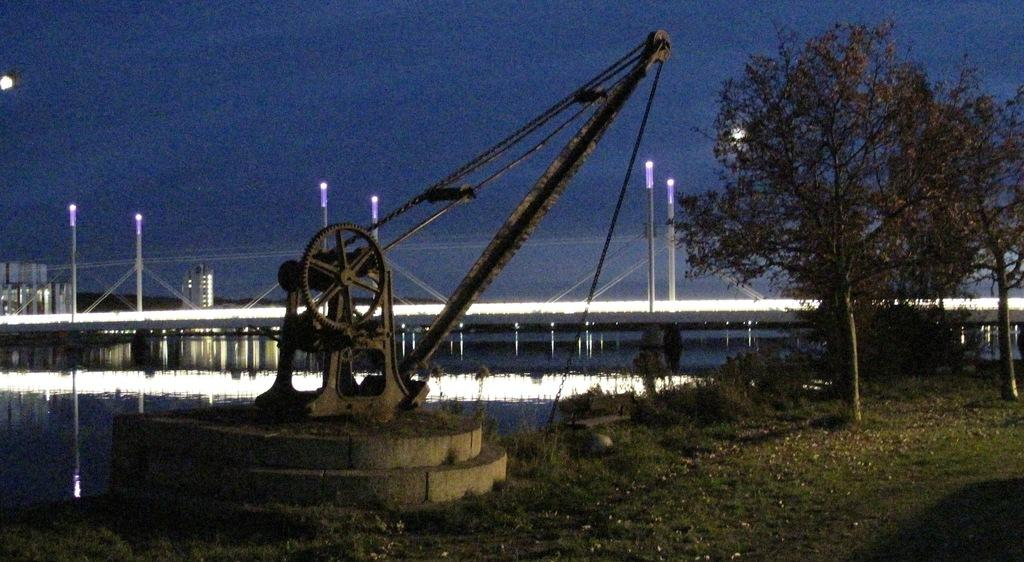What mechanical device is present in the image? There is a pulley in the image. What type of natural environment surrounds the pulley? There is grass beside the pulley. What type of plant can be seen in the image? There is a tree in the image. What body of water is visible in the image? There is a water surface behind the pulley. What type of lighting is present in the background of the image? There are pole lights in the background of the image. What type of quilt is being used to teach the children in the image? There are no children or quilts present in the image; it features a pulley, grass, a tree, a water surface, and pole lights. 